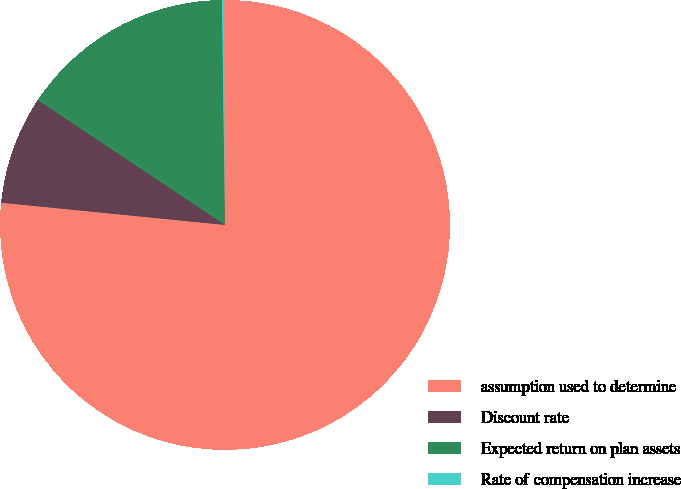<chart> <loc_0><loc_0><loc_500><loc_500><pie_chart><fcel>assumption used to determine<fcel>Discount rate<fcel>Expected return on plan assets<fcel>Rate of compensation increase<nl><fcel>76.67%<fcel>7.78%<fcel>15.43%<fcel>0.12%<nl></chart> 